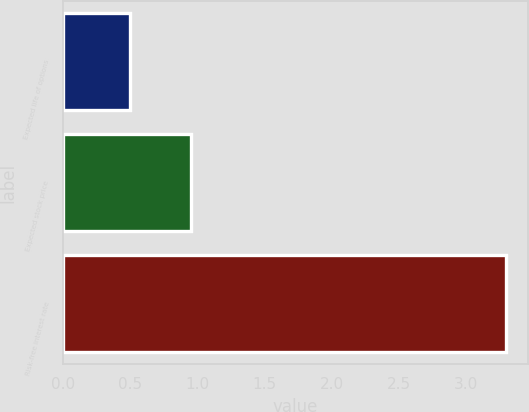Convert chart to OTSL. <chart><loc_0><loc_0><loc_500><loc_500><bar_chart><fcel>Expected life of options<fcel>Expected stock price<fcel>Risk-free interest rate<nl><fcel>0.5<fcel>0.95<fcel>3.3<nl></chart> 